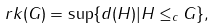Convert formula to latex. <formula><loc_0><loc_0><loc_500><loc_500>r k ( G ) = \sup \{ d ( H ) | H \leq _ { c } G \} ,</formula> 